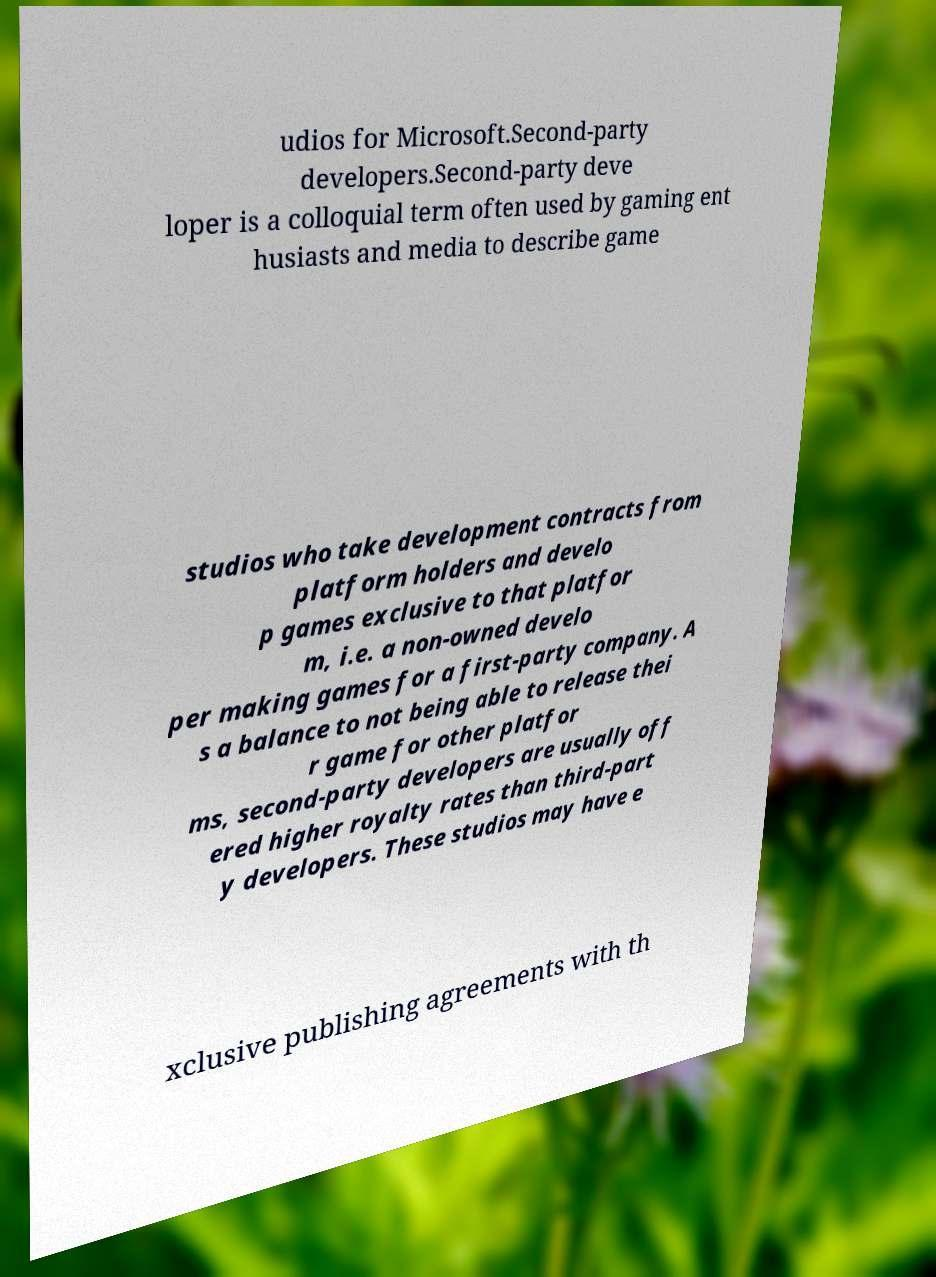Please read and relay the text visible in this image. What does it say? udios for Microsoft.Second-party developers.Second-party deve loper is a colloquial term often used by gaming ent husiasts and media to describe game studios who take development contracts from platform holders and develo p games exclusive to that platfor m, i.e. a non-owned develo per making games for a first-party company. A s a balance to not being able to release thei r game for other platfor ms, second-party developers are usually off ered higher royalty rates than third-part y developers. These studios may have e xclusive publishing agreements with th 